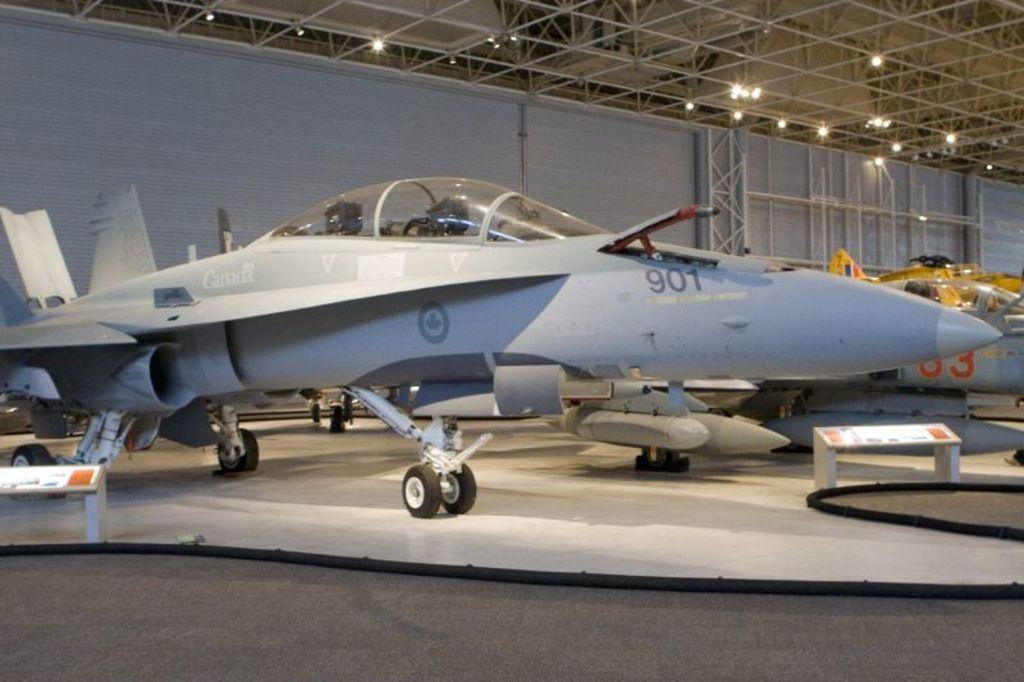What type of vehicles are in the image? There are jet aircrafts in the image. What can be seen illuminated in the image? There are lights visible in the image. What part of a building is shown in the image? The image shows a ceiling. What feature of the jet aircrafts is mentioned in the facts? The jet aircrafts have wheels attached to them. What object is present in the image that might be used for displaying information or instructions? There is a board in the image. What type of coal is being used to clear the throat of the person in the image? There is no person or coal present in the image; it features jet aircrafts and related objects. 